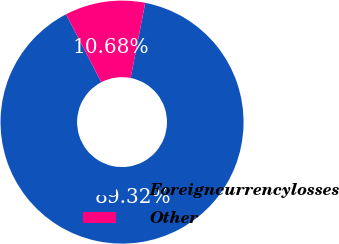<chart> <loc_0><loc_0><loc_500><loc_500><pie_chart><fcel>Foreigncurrencylosses<fcel>Other<nl><fcel>89.32%<fcel>10.68%<nl></chart> 